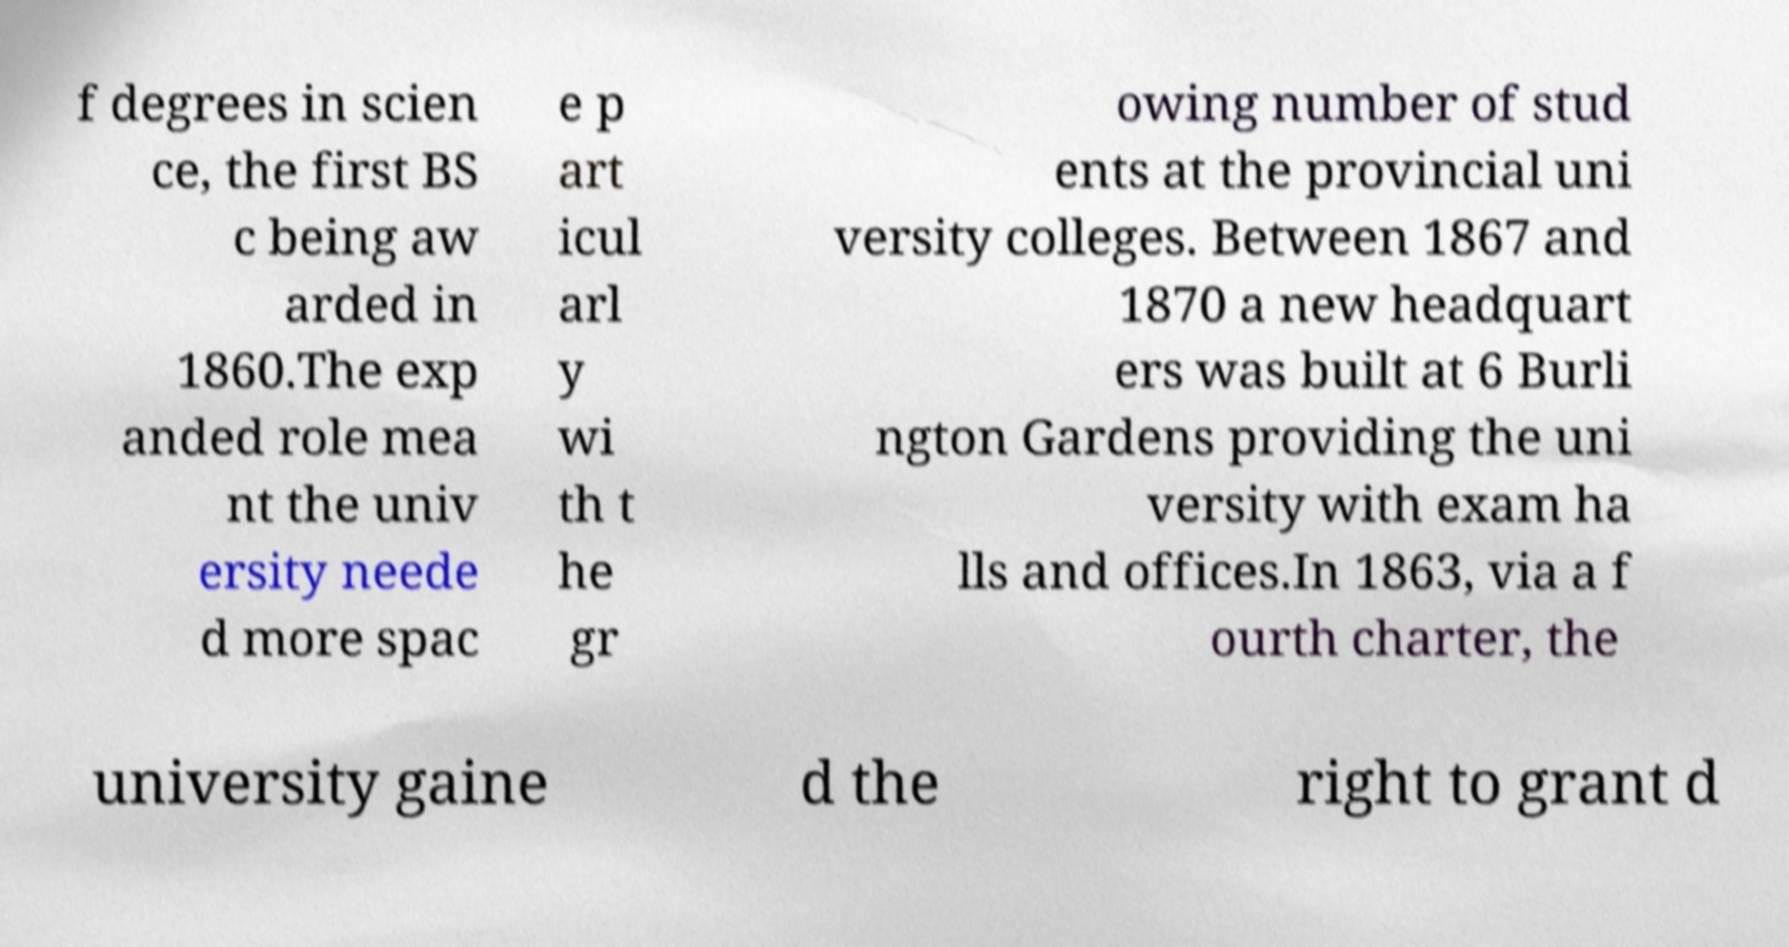Could you extract and type out the text from this image? f degrees in scien ce, the first BS c being aw arded in 1860.The exp anded role mea nt the univ ersity neede d more spac e p art icul arl y wi th t he gr owing number of stud ents at the provincial uni versity colleges. Between 1867 and 1870 a new headquart ers was built at 6 Burli ngton Gardens providing the uni versity with exam ha lls and offices.In 1863, via a f ourth charter, the university gaine d the right to grant d 